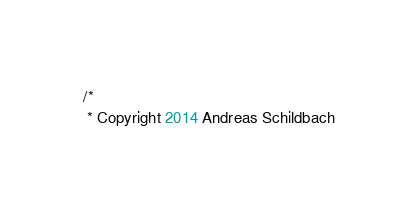Convert code to text. <code><loc_0><loc_0><loc_500><loc_500><_Java_>/*
 * Copyright 2014 Andreas Schildbach</code> 